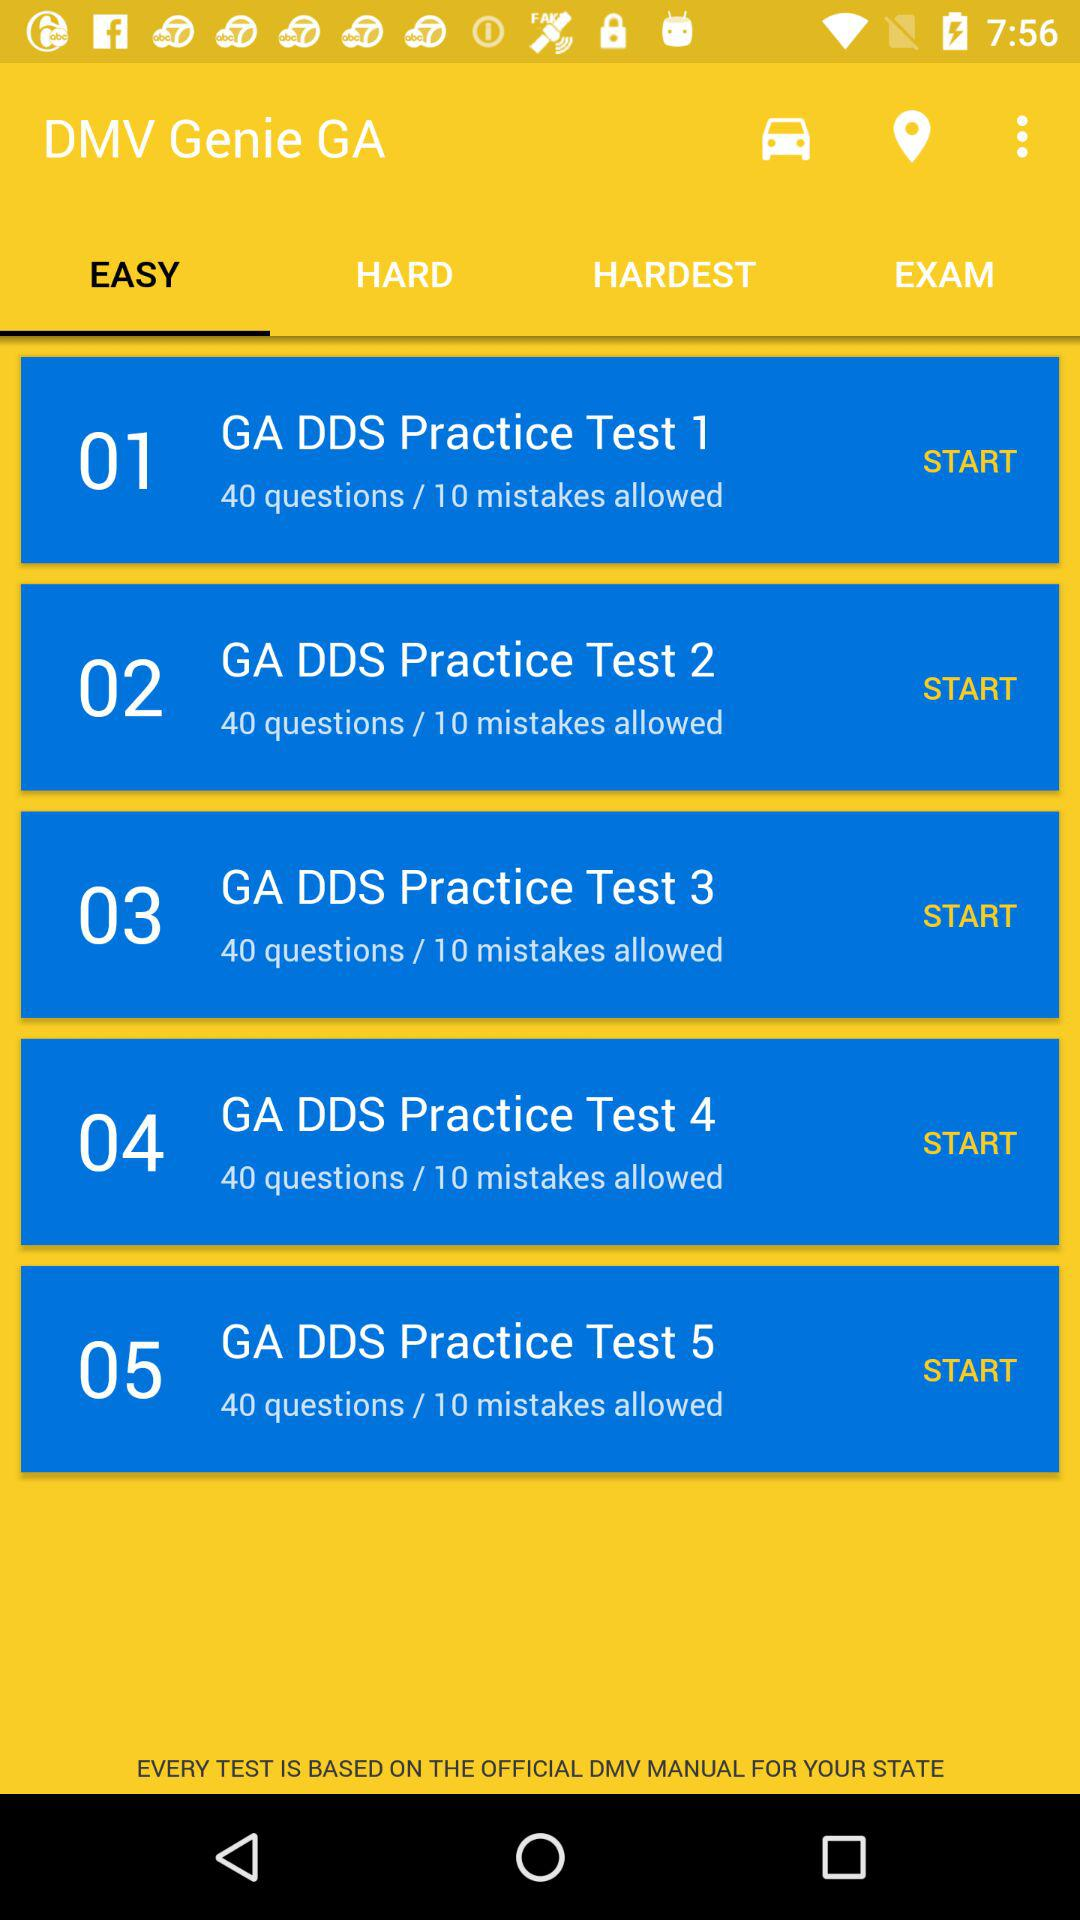How many practice tests are available for the GA DDS?
Answer the question using a single word or phrase. 5 